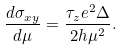Convert formula to latex. <formula><loc_0><loc_0><loc_500><loc_500>\frac { d \sigma _ { x y } } { d \mu } = \frac { \tau _ { z } e ^ { 2 } \Delta } { 2 h \mu ^ { 2 } } .</formula> 